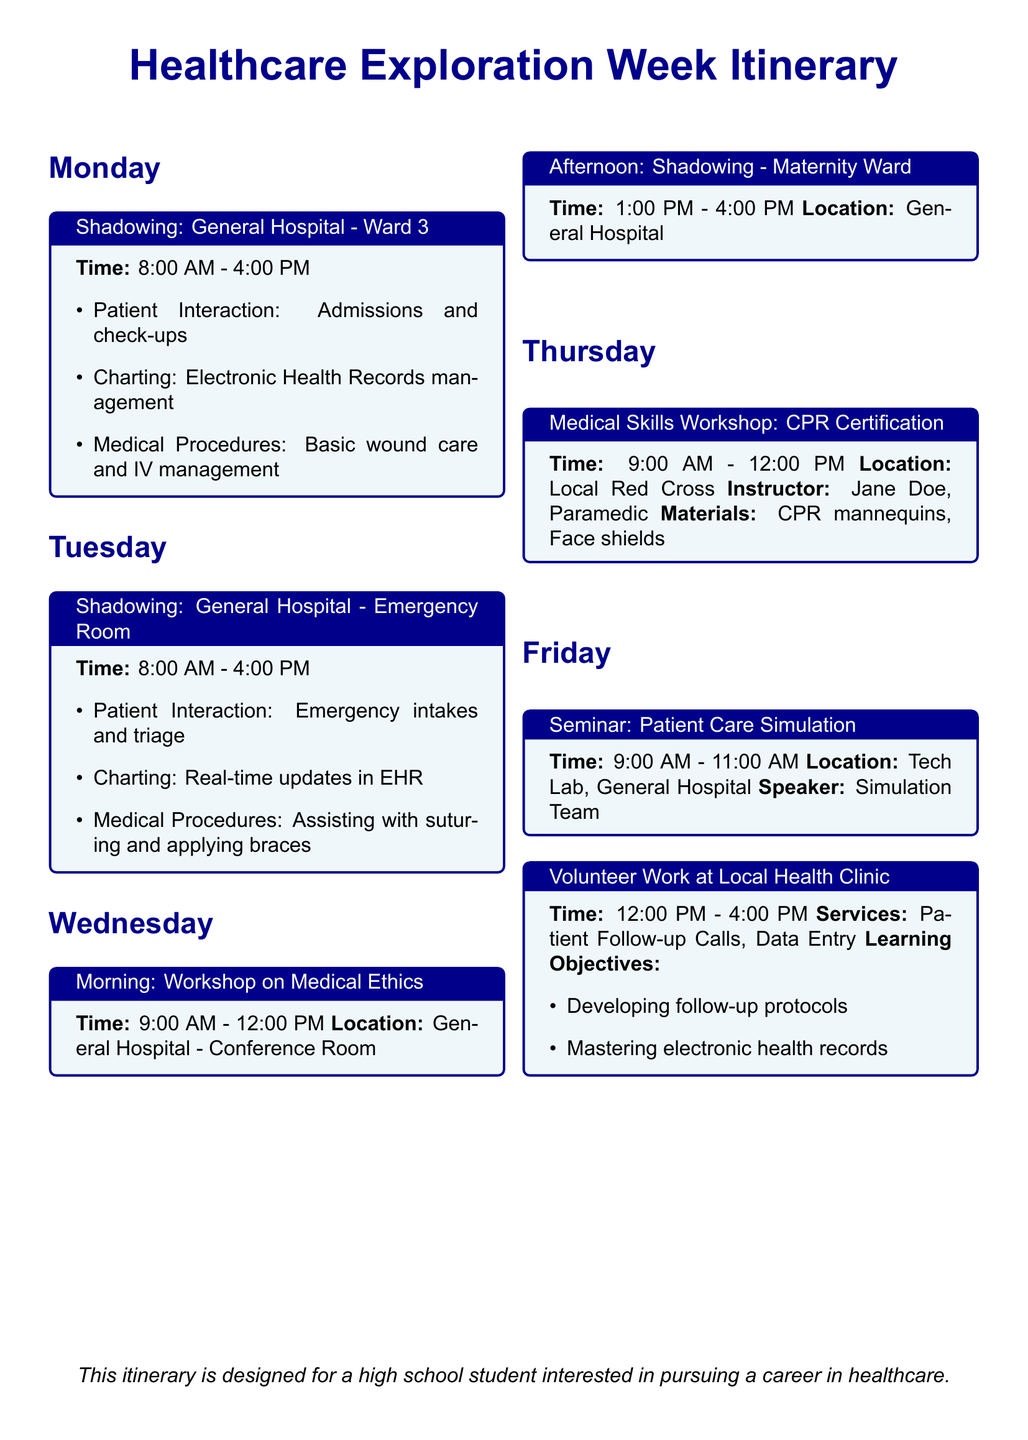what is the time for shadowing at the emergency room? The document states that the shadowing at the emergency room takes place from 8:00 AM to 4:00 PM on Tuesday.
Answer: 8:00 AM - 4:00 PM who is the instructor for the CPR certification workshop? The document mentions that the instructor for the CPR certification workshop is Jane Doe, a Paramedic.
Answer: Jane Doe what type of services is provided during volunteer work at the local health clinic? According to the document, the services provided during volunteer work at the local health clinic include Patient Follow-up Calls and Data Entry.
Answer: Patient Follow-up Calls, Data Entry how long is the medical ethics workshop on Wednesday? The document specifies that the medical ethics workshop on Wednesday lasts for 3 hours, from 9:00 AM to 12:00 PM.
Answer: 3 hours what is the location for the patient care simulation seminar? The document lists the location for the patient care simulation seminar as the Tech Lab in the General Hospital.
Answer: Tech Lab, General Hospital what are the learning objectives for the volunteer work at the local health clinic? The document outlines the learning objectives as developing follow-up protocols and mastering electronic health records.
Answer: Developing follow-up protocols, mastering electronic health records on which day is the maternity ward shadowing scheduled? The document indicates that the maternity ward shadowing is scheduled for Wednesday afternoon from 1:00 PM to 4:00 PM.
Answer: Wednesday afternoon what is the main focus of the shadowing on Monday? The document mentions that the main focus of the shadowing on Monday is Patient Interaction, Charting, and Medical Procedures.
Answer: Patient Interaction, Charting, Medical Procedures 